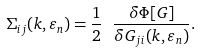Convert formula to latex. <formula><loc_0><loc_0><loc_500><loc_500>\Sigma _ { i j } ( { k } , \varepsilon _ { n } ) = \frac { 1 } { 2 } \ \frac { \delta \Phi [ G ] } { \delta G _ { j i } ( { k } , \varepsilon _ { n } ) } .</formula> 